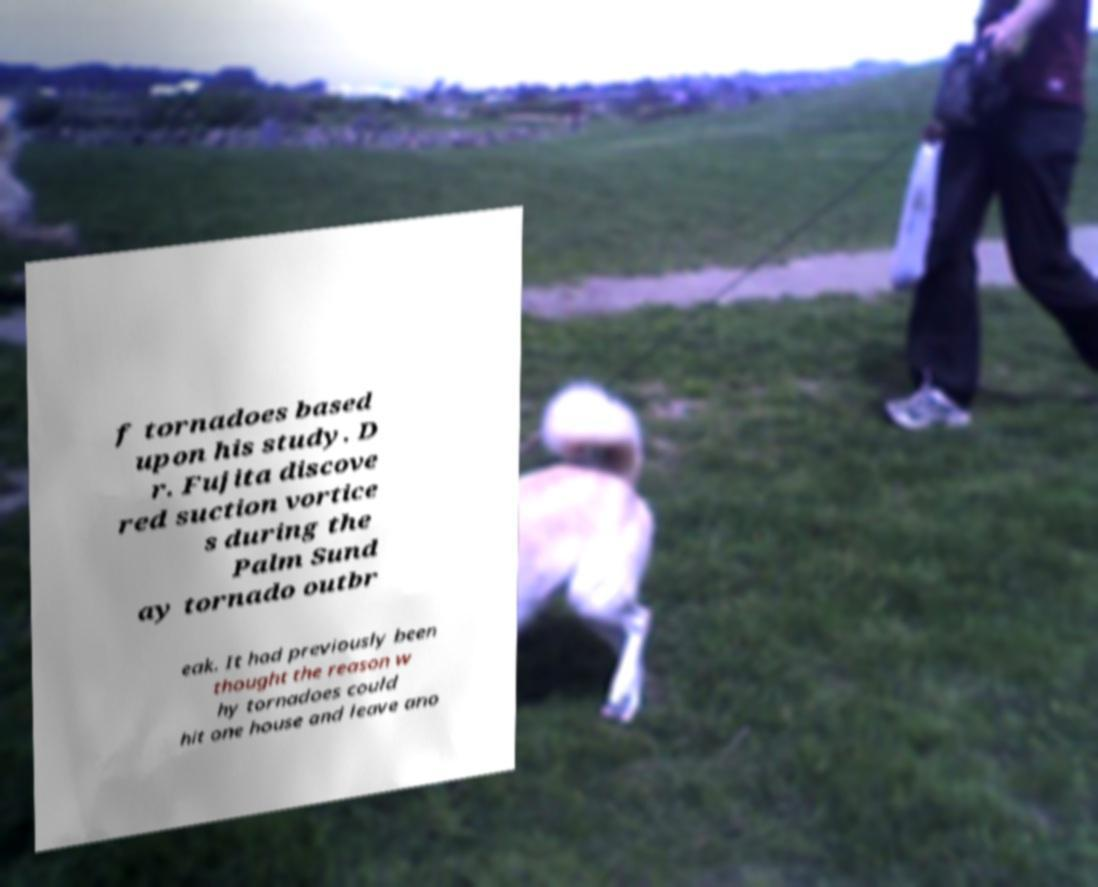Please identify and transcribe the text found in this image. f tornadoes based upon his study. D r. Fujita discove red suction vortice s during the Palm Sund ay tornado outbr eak. It had previously been thought the reason w hy tornadoes could hit one house and leave ano 